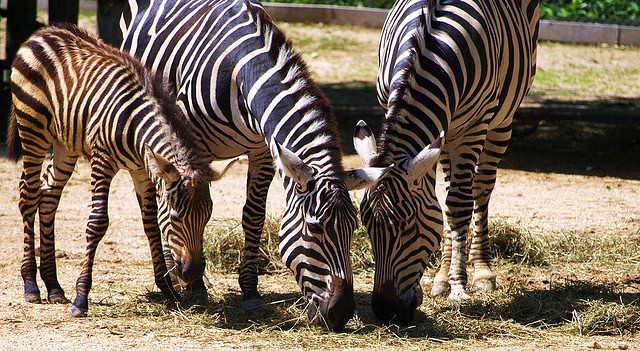Describe the objects in this image and their specific colors. I can see zebra in darkgreen, black, maroon, and gray tones, zebra in darkgreen, black, white, gray, and maroon tones, and zebra in darkgreen, black, maroon, and ivory tones in this image. 